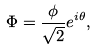Convert formula to latex. <formula><loc_0><loc_0><loc_500><loc_500>\Phi = \frac { \phi } { \sqrt { 2 } } e ^ { i \theta } ,</formula> 